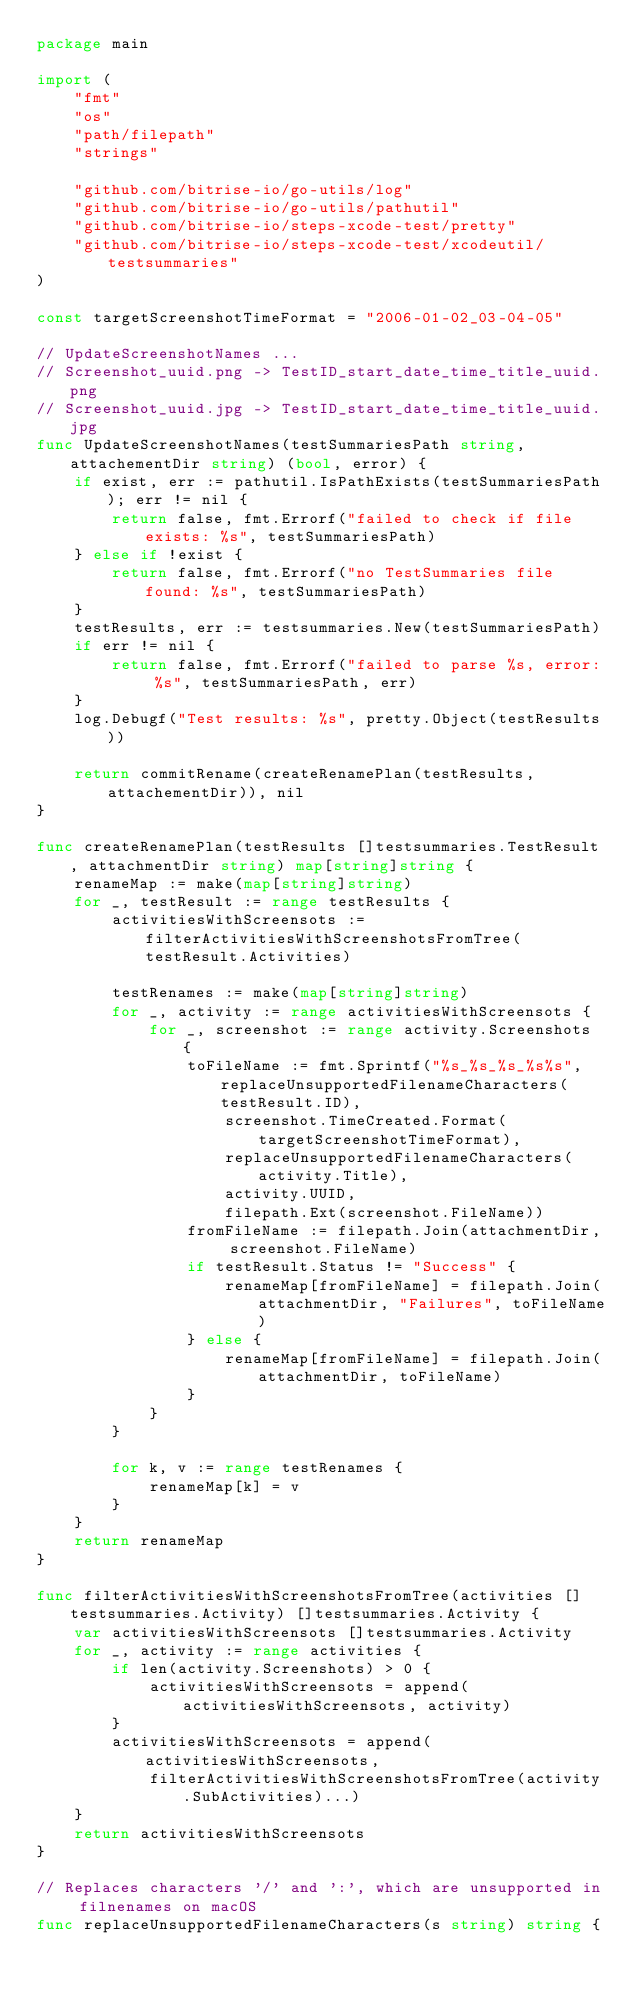Convert code to text. <code><loc_0><loc_0><loc_500><loc_500><_Go_>package main

import (
	"fmt"
	"os"
	"path/filepath"
	"strings"

	"github.com/bitrise-io/go-utils/log"
	"github.com/bitrise-io/go-utils/pathutil"
	"github.com/bitrise-io/steps-xcode-test/pretty"
	"github.com/bitrise-io/steps-xcode-test/xcodeutil/testsummaries"
)

const targetScreenshotTimeFormat = "2006-01-02_03-04-05"

// UpdateScreenshotNames ...
// Screenshot_uuid.png -> TestID_start_date_time_title_uuid.png
// Screenshot_uuid.jpg -> TestID_start_date_time_title_uuid.jpg
func UpdateScreenshotNames(testSummariesPath string, attachementDir string) (bool, error) {
	if exist, err := pathutil.IsPathExists(testSummariesPath); err != nil {
		return false, fmt.Errorf("failed to check if file exists: %s", testSummariesPath)
	} else if !exist {
		return false, fmt.Errorf("no TestSummaries file found: %s", testSummariesPath)
	}
	testResults, err := testsummaries.New(testSummariesPath)
	if err != nil {
		return false, fmt.Errorf("failed to parse %s, error: %s", testSummariesPath, err)
	}
	log.Debugf("Test results: %s", pretty.Object(testResults))

	return commitRename(createRenamePlan(testResults, attachementDir)), nil
}

func createRenamePlan(testResults []testsummaries.TestResult, attachmentDir string) map[string]string {
	renameMap := make(map[string]string)
	for _, testResult := range testResults {
		activitiesWithScreensots := filterActivitiesWithScreenshotsFromTree(testResult.Activities)

		testRenames := make(map[string]string)
		for _, activity := range activitiesWithScreensots {
			for _, screenshot := range activity.Screenshots {
				toFileName := fmt.Sprintf("%s_%s_%s_%s%s", replaceUnsupportedFilenameCharacters(testResult.ID),
					screenshot.TimeCreated.Format(targetScreenshotTimeFormat),
					replaceUnsupportedFilenameCharacters(activity.Title),
					activity.UUID,
					filepath.Ext(screenshot.FileName))
				fromFileName := filepath.Join(attachmentDir, screenshot.FileName)
				if testResult.Status != "Success" {
					renameMap[fromFileName] = filepath.Join(attachmentDir, "Failures", toFileName)
				} else {
					renameMap[fromFileName] = filepath.Join(attachmentDir, toFileName)
				}
			}
		}

		for k, v := range testRenames {
			renameMap[k] = v
		}
	}
	return renameMap
}

func filterActivitiesWithScreenshotsFromTree(activities []testsummaries.Activity) []testsummaries.Activity {
	var activitiesWithScreensots []testsummaries.Activity
	for _, activity := range activities {
		if len(activity.Screenshots) > 0 {
			activitiesWithScreensots = append(activitiesWithScreensots, activity)
		}
		activitiesWithScreensots = append(activitiesWithScreensots,
			filterActivitiesWithScreenshotsFromTree(activity.SubActivities)...)
	}
	return activitiesWithScreensots
}

// Replaces characters '/' and ':', which are unsupported in filnenames on macOS
func replaceUnsupportedFilenameCharacters(s string) string {</code> 